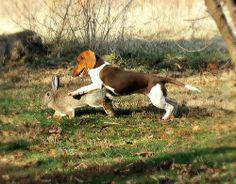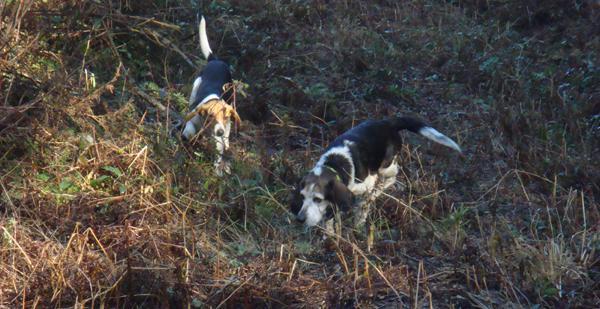The first image is the image on the left, the second image is the image on the right. Given the left and right images, does the statement "There are exactly two animals in the image on the left." hold true? Answer yes or no. Yes. 